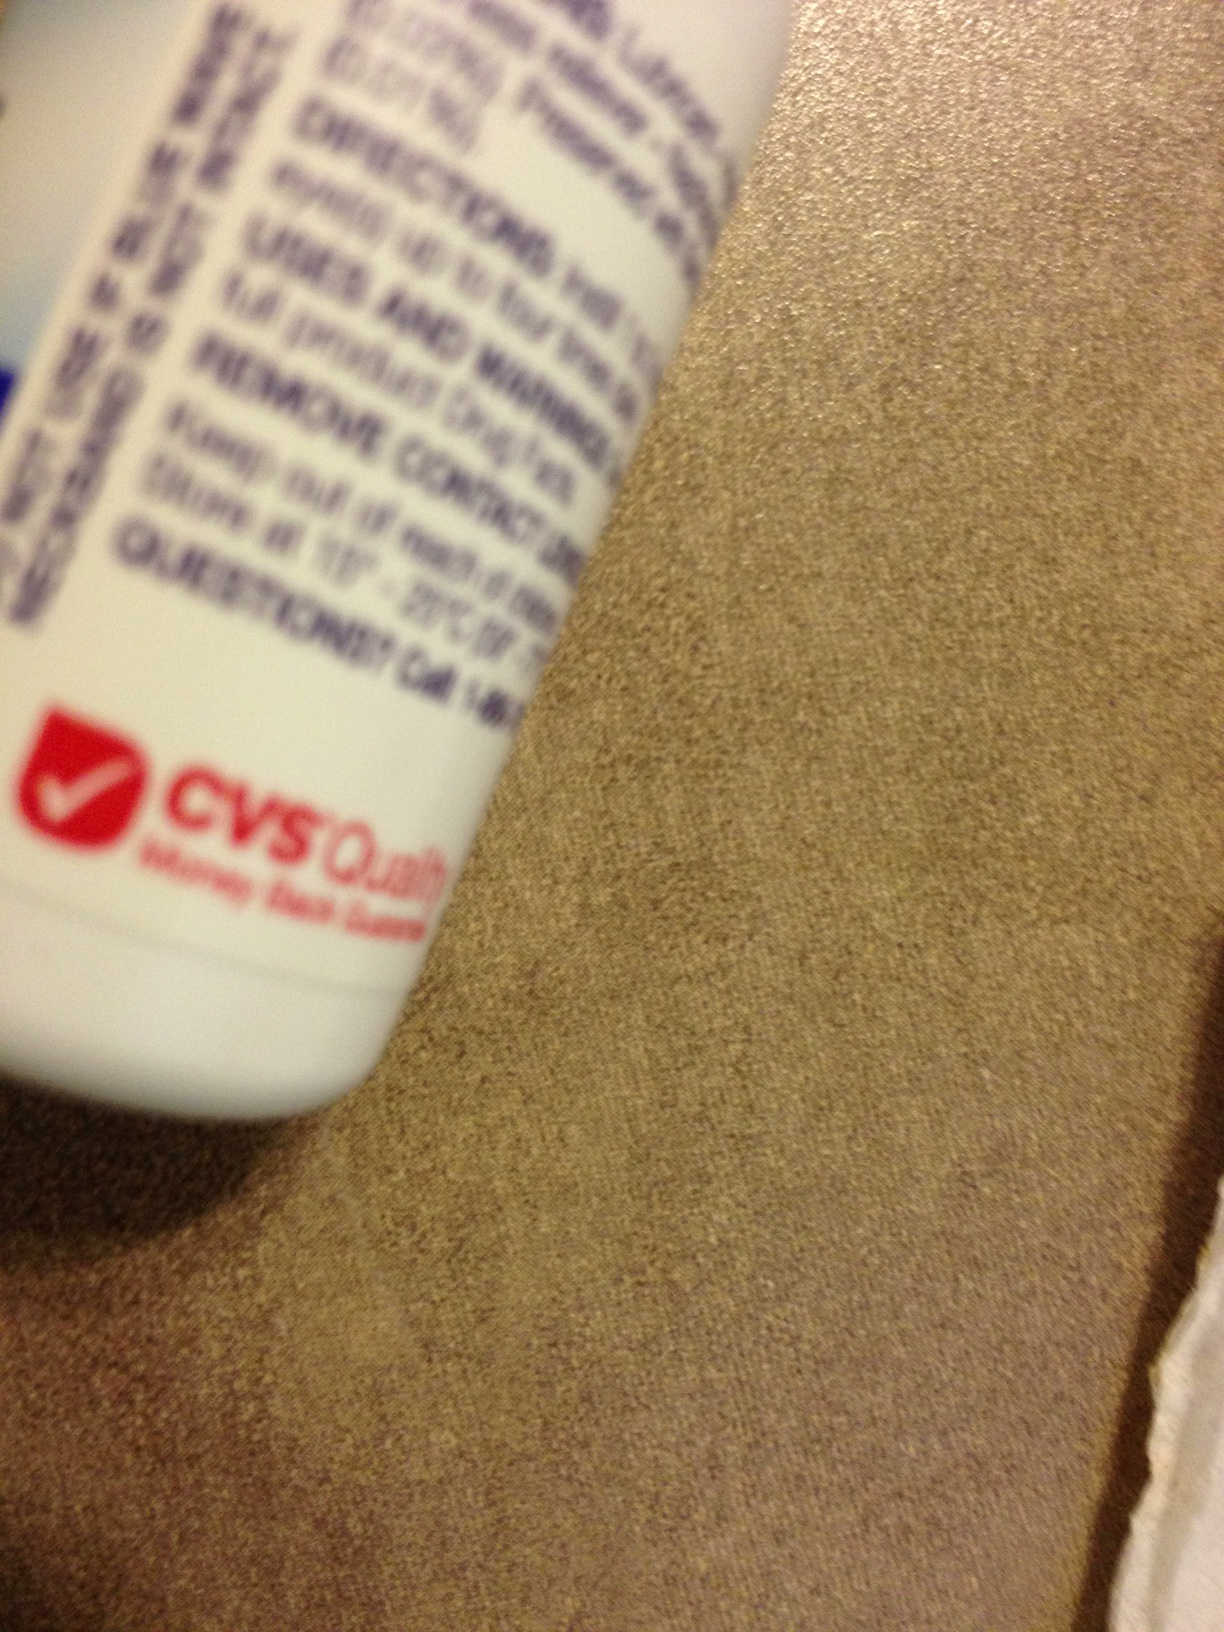Can you tell me what this product is used for? The product appears to be a health or personal care item from CVS. The partial label suggests it may be used for eye care or potentially as a medicinal solution, but without clear visibility of the product's full name or usage instructions, a specific application cannot be provided. 